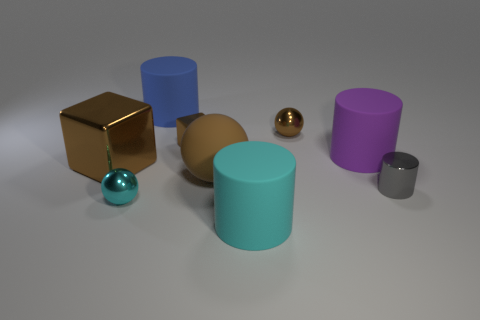There is a large thing that is the same color as the large ball; what shape is it?
Provide a short and direct response. Cube. There is a large matte thing that is in front of the small cylinder; is its shape the same as the purple thing?
Provide a succinct answer. Yes. How many things are brown metallic objects that are behind the big metallic cube or purple rubber things?
Keep it short and to the point. 3. Is there a big rubber object that has the same shape as the large metallic thing?
Provide a short and direct response. No. What shape is the purple rubber object that is the same size as the rubber ball?
Provide a short and direct response. Cylinder. There is a big brown matte thing that is behind the small cyan metal sphere to the left of the matte cylinder that is in front of the tiny gray object; what shape is it?
Your response must be concise. Sphere. Do the tiny gray object and the brown shiny thing to the right of the big brown rubber thing have the same shape?
Make the answer very short. No. How many tiny objects are spheres or shiny cubes?
Make the answer very short. 3. Are there any brown matte spheres that have the same size as the cyan rubber object?
Make the answer very short. Yes. What is the color of the large rubber cylinder that is in front of the small metal thing that is to the left of the big cylinder behind the purple matte object?
Ensure brevity in your answer.  Cyan. 